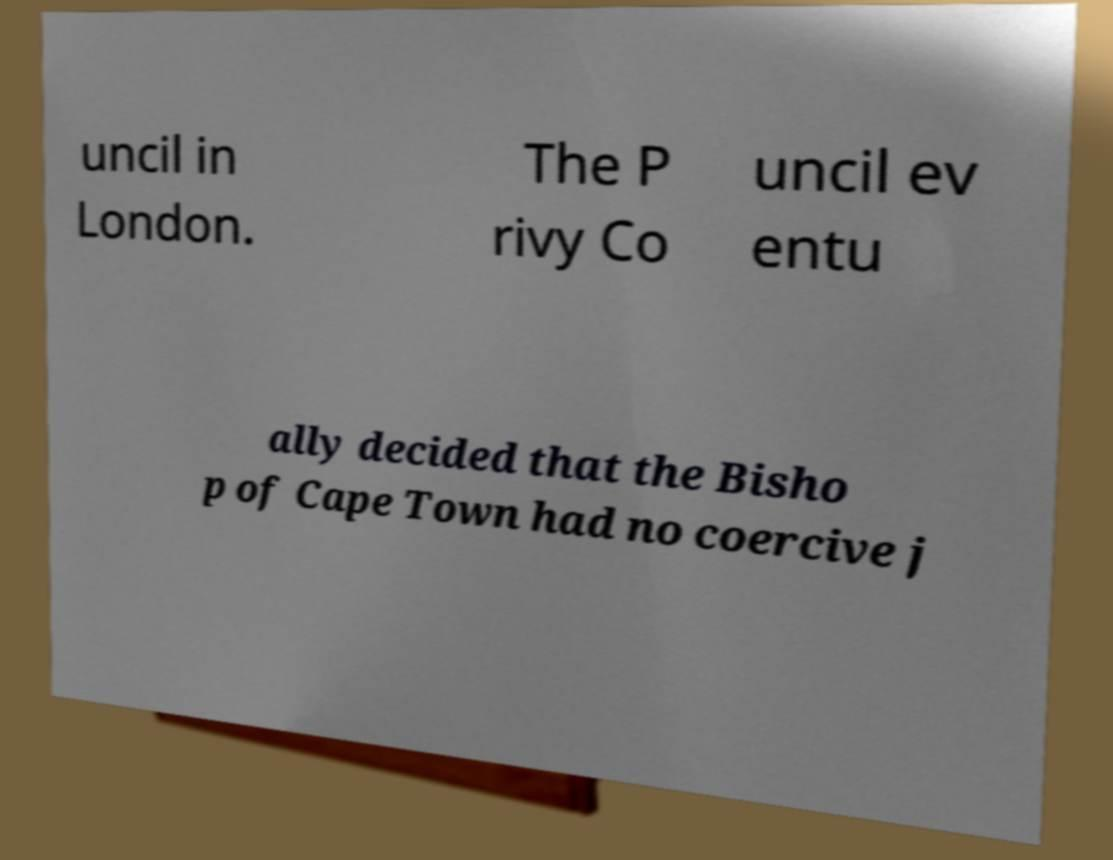Please read and relay the text visible in this image. What does it say? uncil in London. The P rivy Co uncil ev entu ally decided that the Bisho p of Cape Town had no coercive j 